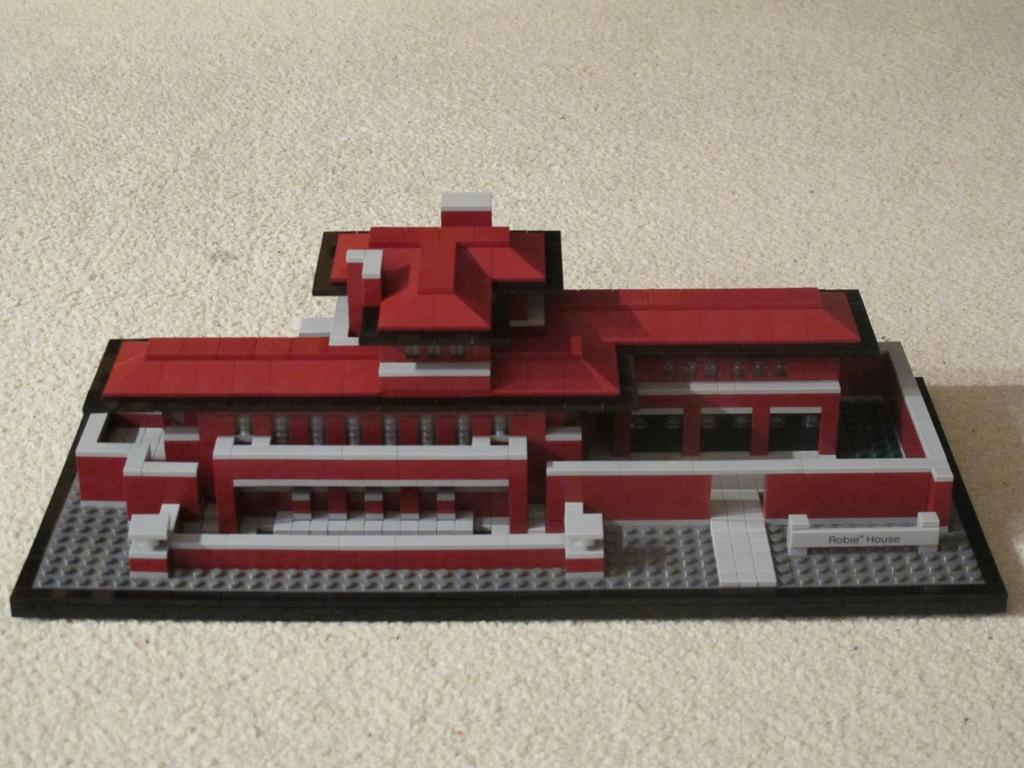What is the main subject of the image? The main subject of the image is a miniature building. What is the building placed on? The miniature building is on a cream-colored surface. What colors can be seen on the building? The building has red, cream, and ash colors. What type of space effect can be seen around the miniature building in the image? There is no space effect present in the image; it features a miniature building on a cream-colored surface with red, cream, and ash colors. Can you describe the skateboarding tricks performed by the miniature building in the image? There is no skateboarding or any other activity involving the miniature building in the image. 